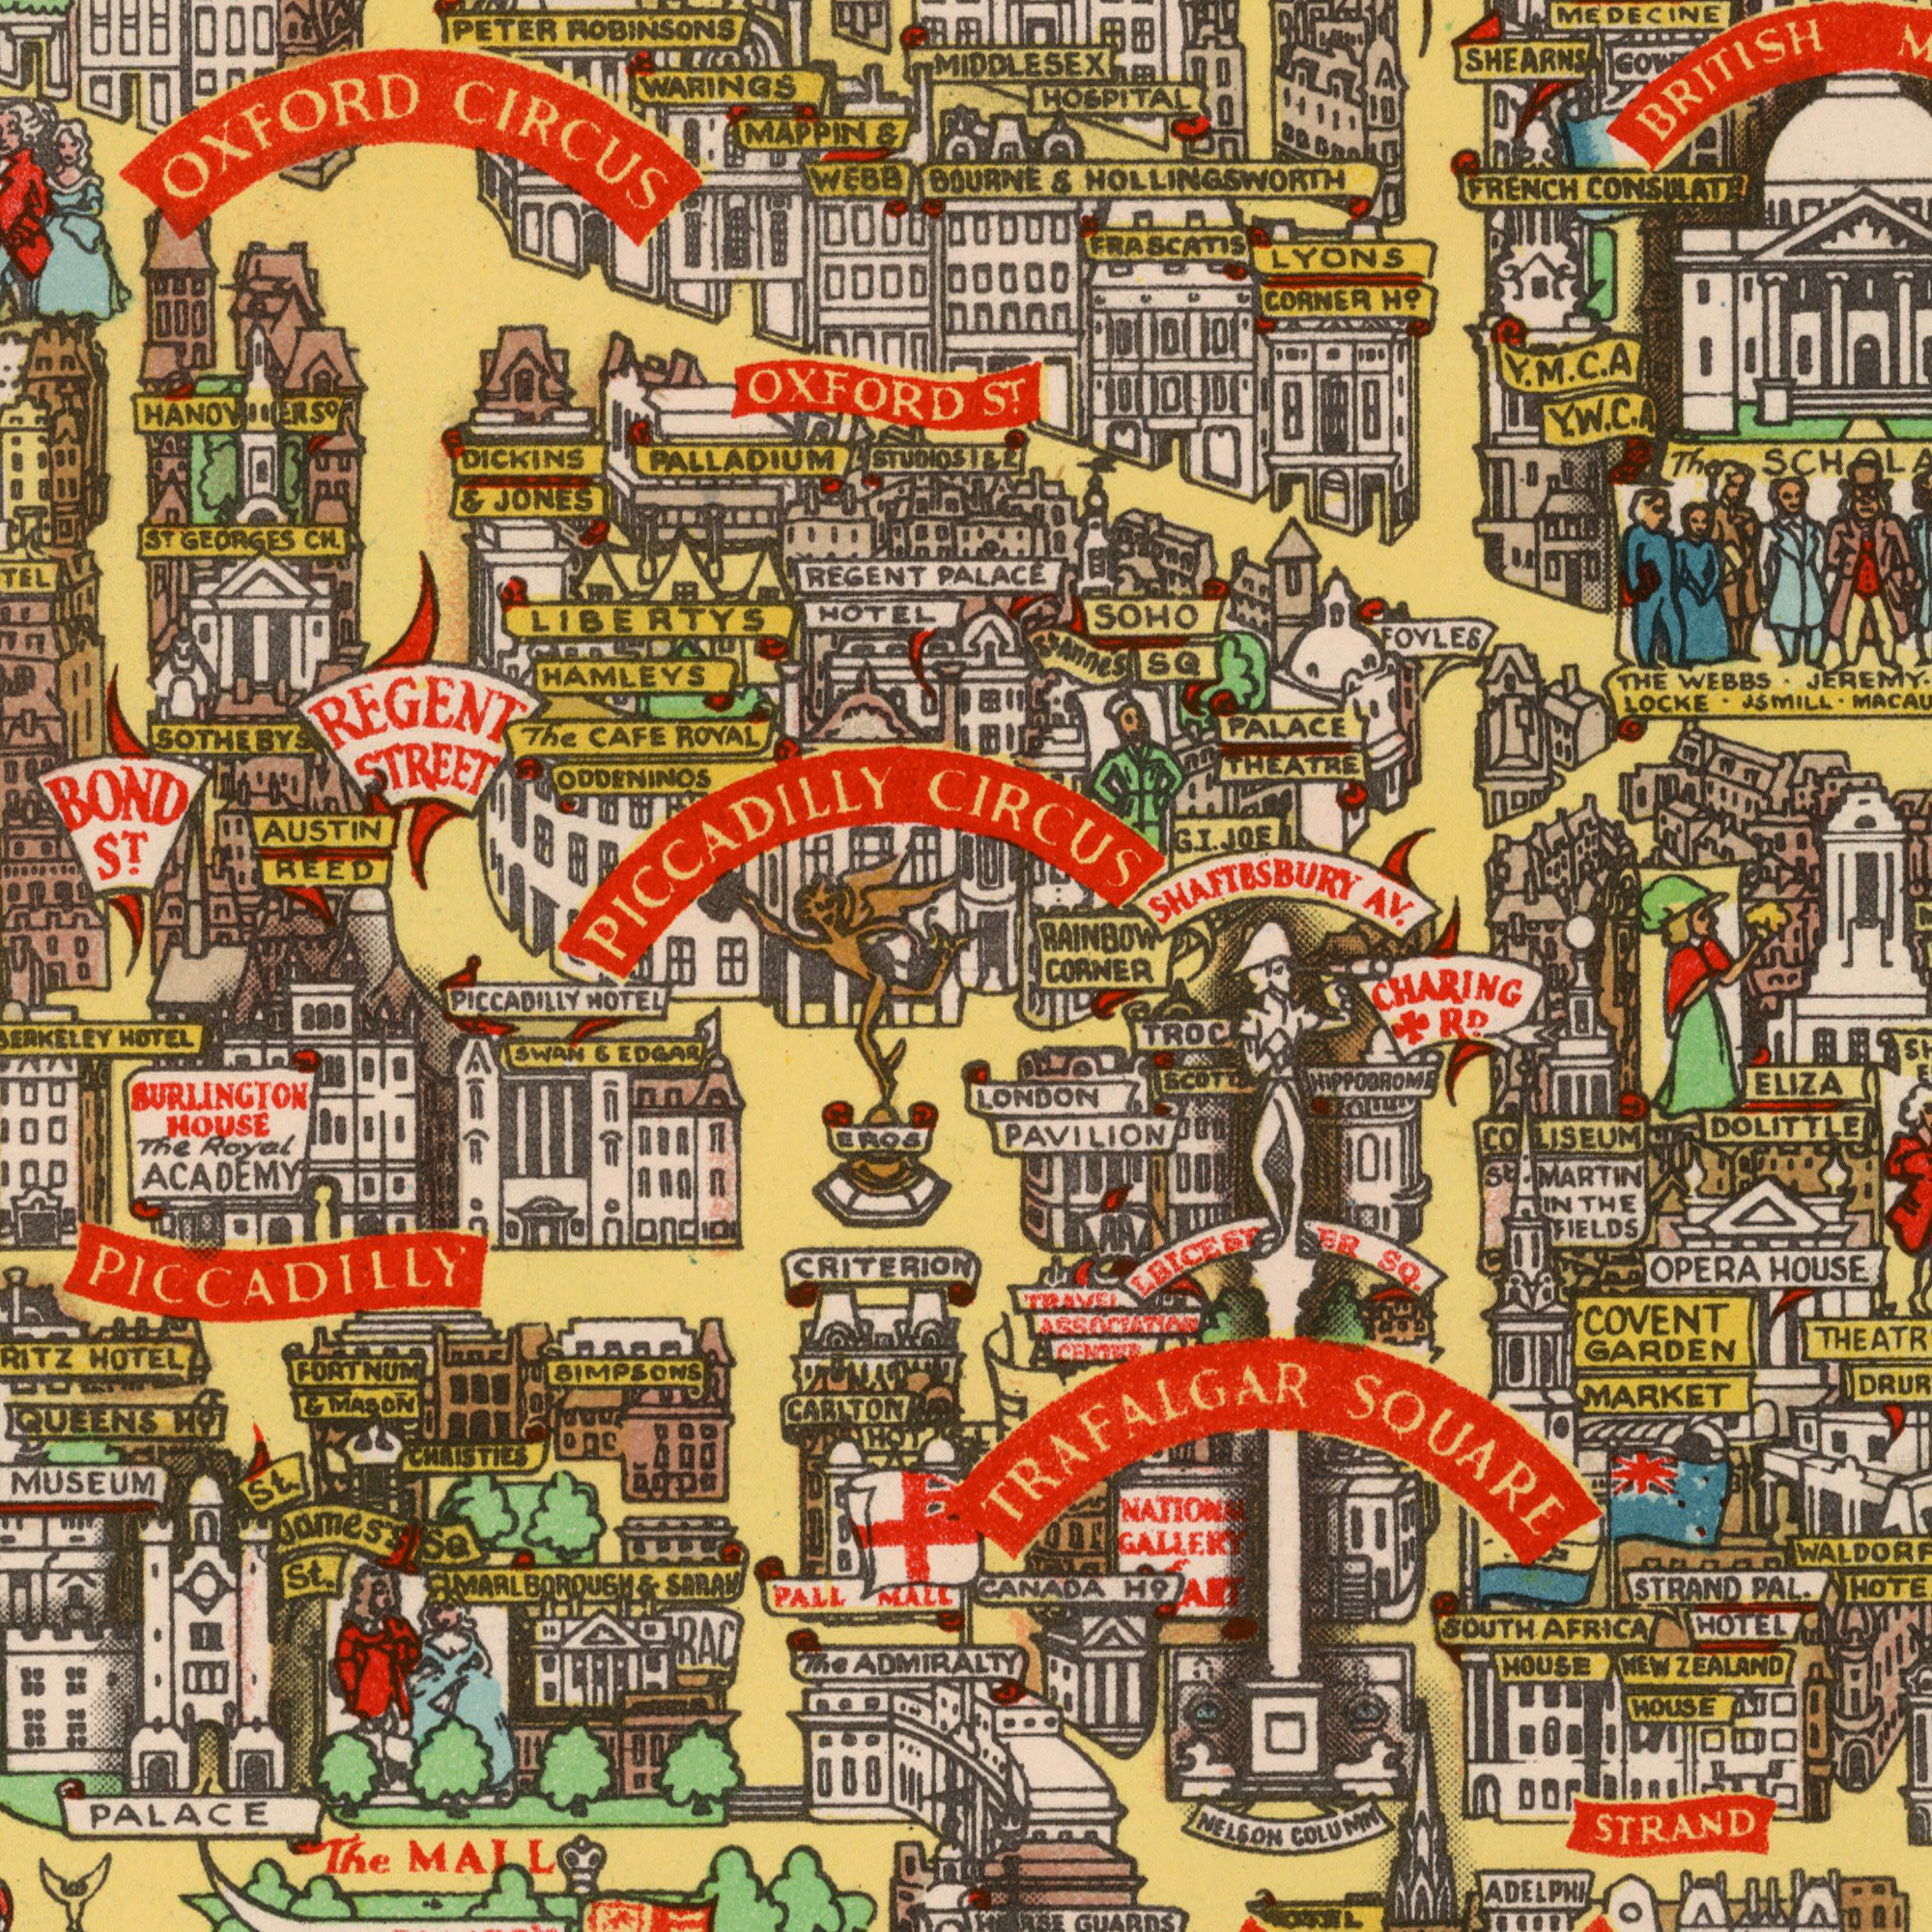What text can you see in the top-right section? SHAFTESBURY SOHO AV. FRENCH PALACE CORNER HOSPITAL RAINBOW JEREMY. WEBBS. LOCKE. SQ LYONS THE THEATRE The Annes CONSULATE JSMILL. HOLLINGSWORTH MIDDLESEX BOURNE & Ho. BRITISH ST. Y. M. C. A Y. W. C. A 1 & 2 PALACE G. JOE CIRCUS I. St FRASCATIS FOYLES MEDECINE SHEARNS What text is shown in the bottom-right quadrant? MARKET CHARING LONDON COVENT OPERA ELIZA GARDEN HOUSE STRAND HOUSE SOUTH COLUMN HOUSE PAL. NELSON MARTIN AFRICA HOTEL NATIONS CANADA GUARDS SQUARE H9 GALLERY RD. DOLITTLE SQ. PAVILION TRAFALGAR CORNER CO. LISEUM ST. IN THE FIELDS TRAVEL ASSOCIATION CENTER ART NEW ZEALAND STRAND ADELPHI TROC SCOTD HIPPOBROM## What text is visible in the upper-left corner? ROBINSONS BOND ODDENINOS ST. MAPPIN AUSTIN JONES WEBB DICKINS CAFE HAMLEYS WARINGS PETER REED ROYAL REGENT The GEORGES CH. LIBERTYS HOTEL STUDIOS ST & & CIRCUS OXFORD REGENT OXFORD PICCADILLY STREET SOTHEBYS PALLADIUM What text can you see in the bottom-left section? ACADEMY CARLTON HOTEL Royal The HOUSE St. PALL The HOTEL SQ QUEENS St. PICCADILLY James's SARAH SURLINGTON MALL EDGAR The MARLBOROUGH SWAN MALL HOTEL & Ho. FORTNUM & MASON & ADMIRALTY HOT MUSEUM PALACE PICCADILLY EROS CRITERION CHRISTIES BIMPSONS RAC 